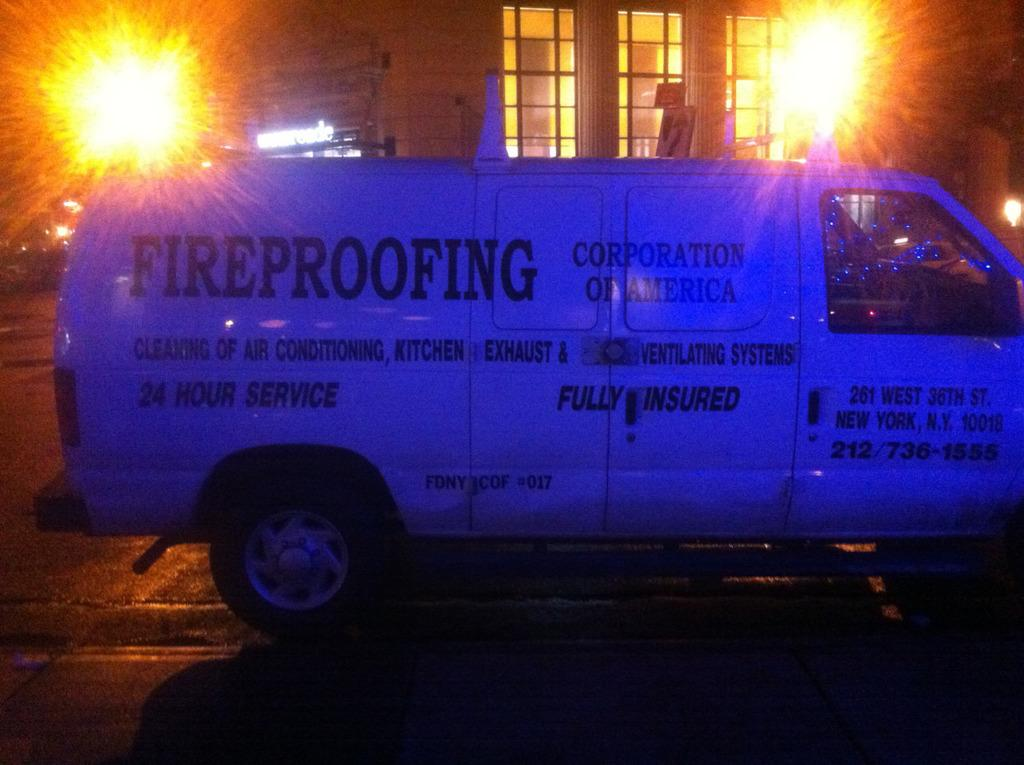<image>
Render a clear and concise summary of the photo. a van for Fireproofing outside at night time 